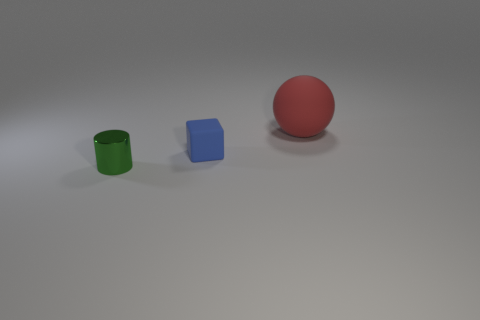Are there any other things that have the same material as the small cylinder?
Ensure brevity in your answer.  No. There is a matte thing in front of the matte object that is to the right of the small thing that is behind the small green metal object; what color is it?
Your response must be concise. Blue. Is there another object that has the same shape as the green thing?
Keep it short and to the point. No. Are there an equal number of metal things on the right side of the green cylinder and green shiny objects that are right of the tiny blue thing?
Provide a succinct answer. Yes. There is a thing that is behind the tiny blue rubber thing; does it have the same shape as the blue rubber object?
Your response must be concise. No. Is the big red rubber thing the same shape as the small green metal object?
Your answer should be compact. No. What number of matte objects are large brown objects or green things?
Provide a short and direct response. 0. Do the rubber sphere and the cylinder have the same size?
Keep it short and to the point. No. What number of things are either gray matte objects or matte objects in front of the big rubber object?
Your response must be concise. 1. There is a blue cube that is the same size as the cylinder; what is it made of?
Your response must be concise. Rubber. 